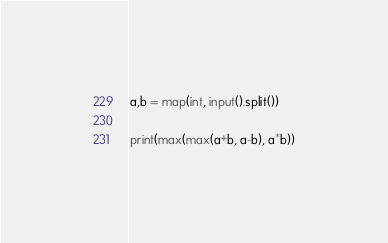Convert code to text. <code><loc_0><loc_0><loc_500><loc_500><_Python_>a,b = map(int, input().split())

print(max(max(a+b, a-b), a*b))</code> 